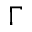Convert formula to latex. <formula><loc_0><loc_0><loc_500><loc_500>\Gamma</formula> 